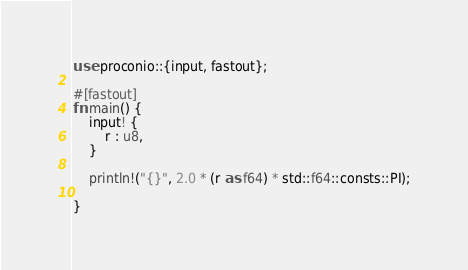Convert code to text. <code><loc_0><loc_0><loc_500><loc_500><_Rust_>use proconio::{input, fastout};

#[fastout]
fn main() {
    input! {
        r : u8,
    }

    println!("{}", 2.0 * (r as f64) * std::f64::consts::PI);

}
</code> 